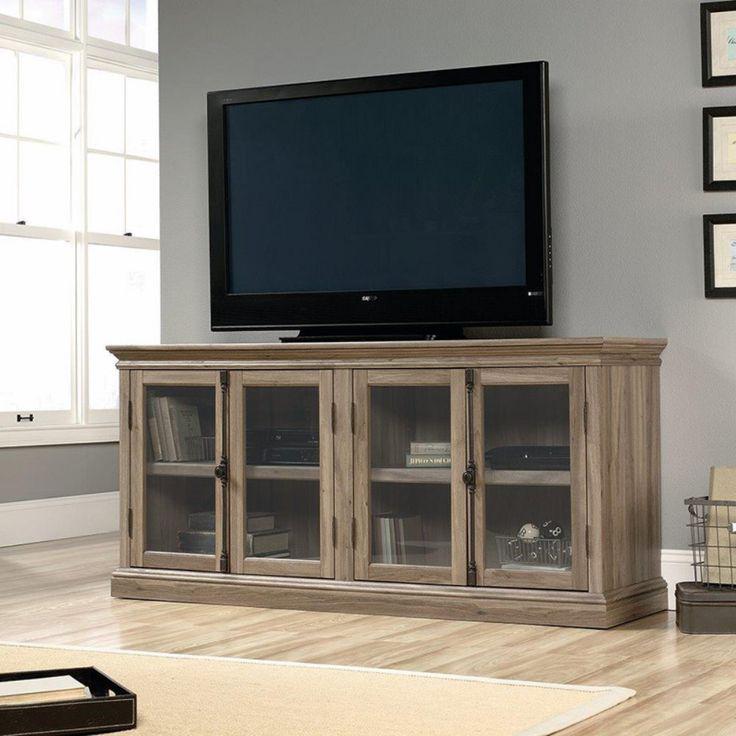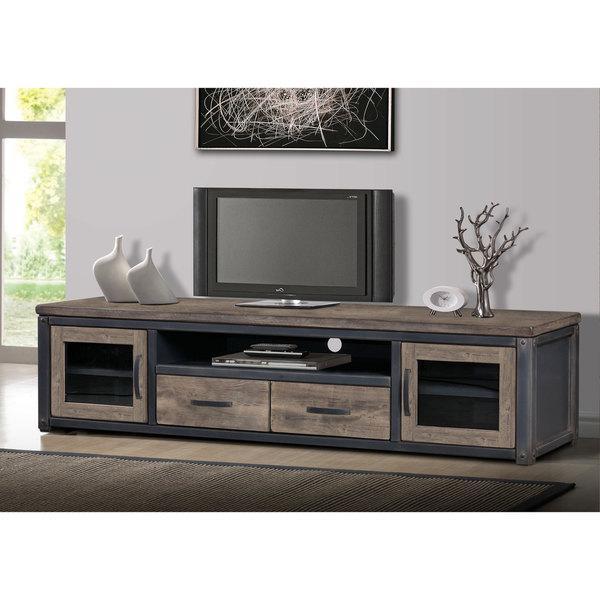The first image is the image on the left, the second image is the image on the right. Examine the images to the left and right. Is the description "A flat screen television is sitting against a wall on a low wooden cabinet that has four glass-fronted doors." accurate? Answer yes or no. Yes. The first image is the image on the left, the second image is the image on the right. Analyze the images presented: Is the assertion "The TV stands on the left and right are similar styles, with the same dark wood and approximately the same configuration of compartments." valid? Answer yes or no. No. 